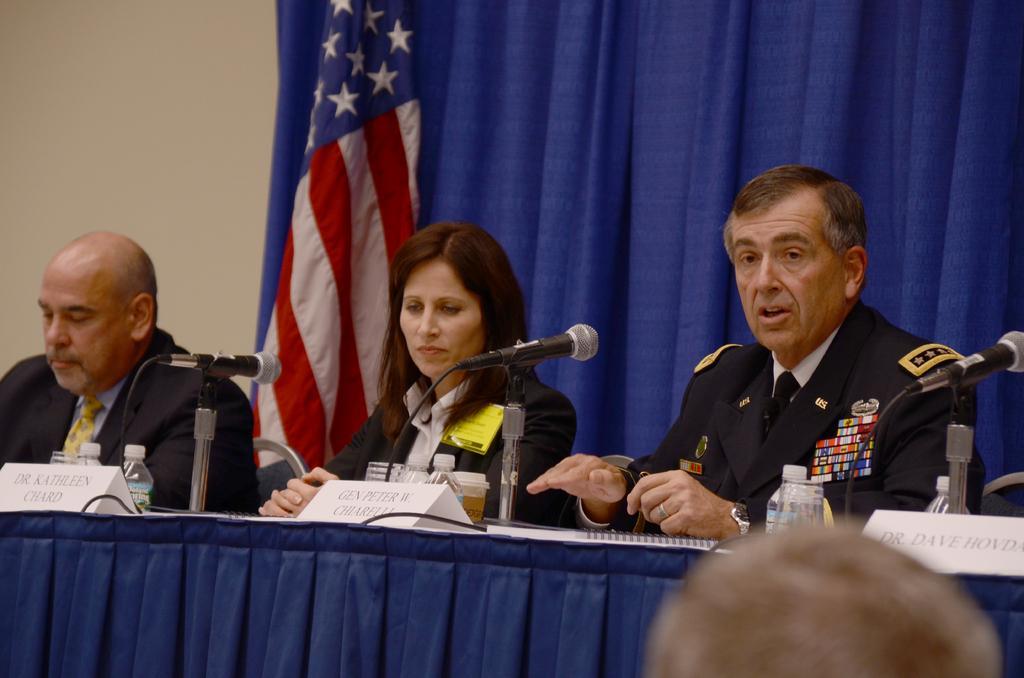Can you describe this image briefly? In this image in the front there is an object which is brown in colour. In the center there is a table which is covered with a blue colour cloth and on the top of the table there are boards with some text written on it, there are bottles, mics and behind the table there are persons sitting. In the background there is a flag and there is a curtain which is blue in colour. 